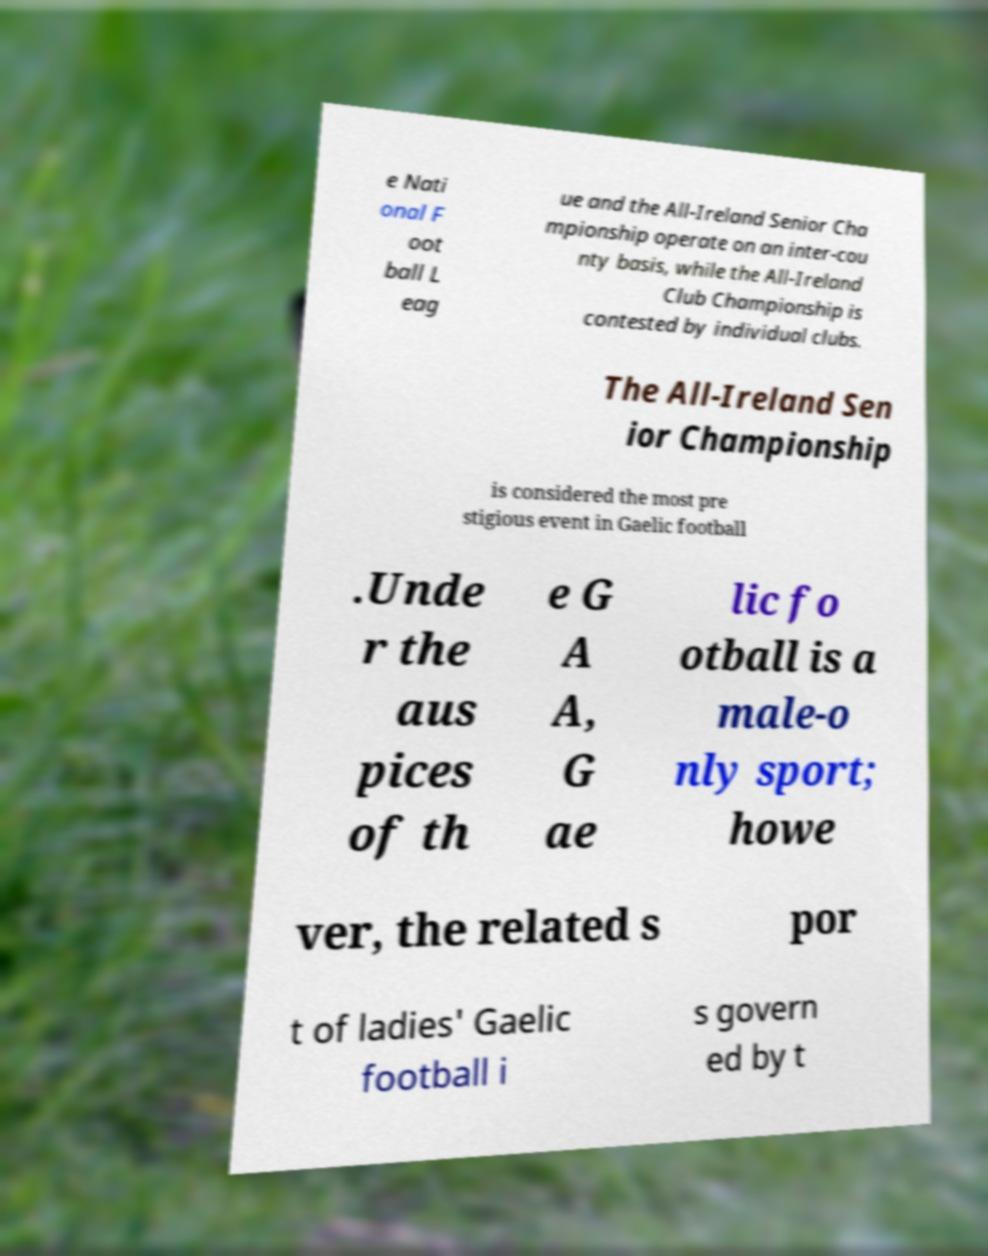Please read and relay the text visible in this image. What does it say? e Nati onal F oot ball L eag ue and the All-Ireland Senior Cha mpionship operate on an inter-cou nty basis, while the All-Ireland Club Championship is contested by individual clubs. The All-Ireland Sen ior Championship is considered the most pre stigious event in Gaelic football .Unde r the aus pices of th e G A A, G ae lic fo otball is a male-o nly sport; howe ver, the related s por t of ladies' Gaelic football i s govern ed by t 